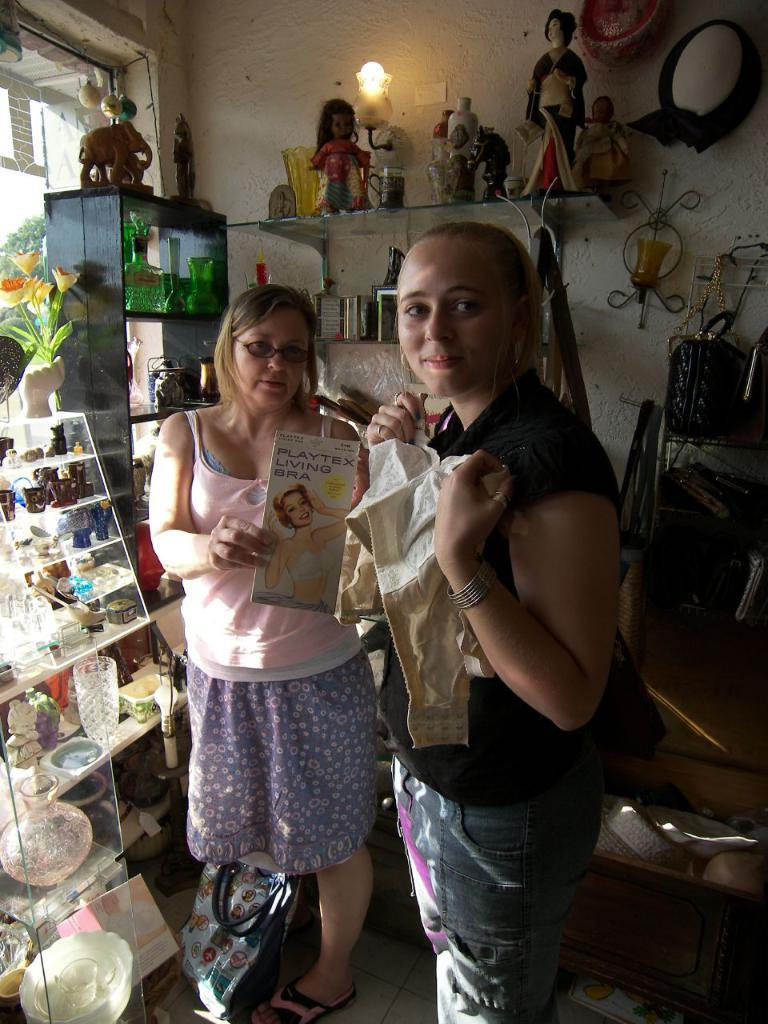How many women are in the image? There are two women standing in the middle of the image. What are the women holding in the image? The women are holding a cloth and a book. What can be seen in the background of the image? There is a wall in the background of the image. What items are on the wall? There are glasses, bottles, and toys on the wall. What type of worm can be seen crawling on the book in the image? There is no worm present in the image; the women are holding a cloth and a book. 